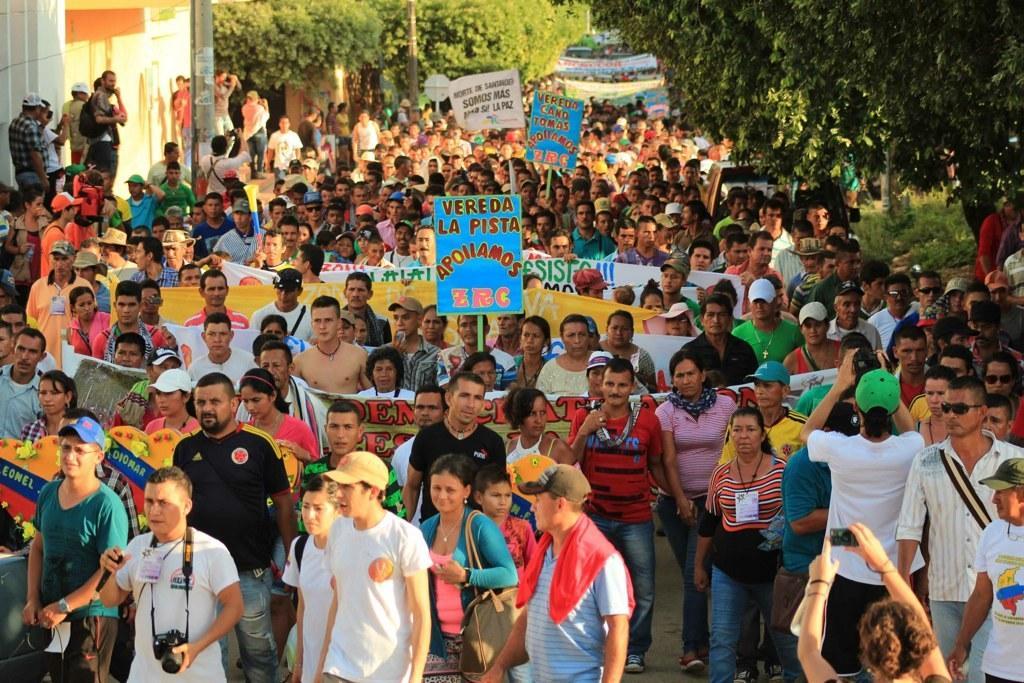How would you summarize this image in a sentence or two? In the image few people are standing and holding banners and cameras and bags. Behind them there are some trees and buildings and poles. 